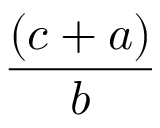<formula> <loc_0><loc_0><loc_500><loc_500>\frac { ( c + a ) } { b }</formula> 